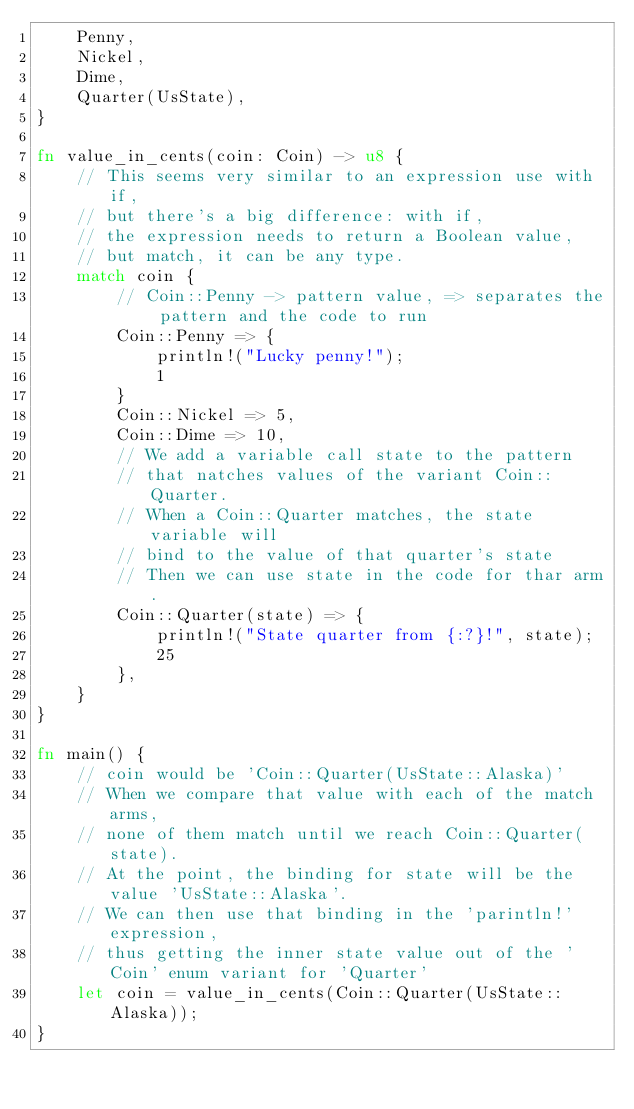Convert code to text. <code><loc_0><loc_0><loc_500><loc_500><_Rust_>    Penny,
    Nickel,
    Dime,
    Quarter(UsState),
}

fn value_in_cents(coin: Coin) -> u8 {
    // This seems very similar to an expression use with if,
    // but there's a big difference: with if,
    // the expression needs to return a Boolean value,
    // but match, it can be any type.
    match coin {
        // Coin::Penny -> pattern value, => separates the pattern and the code to run
        Coin::Penny => {
            println!("Lucky penny!");
            1
        }
        Coin::Nickel => 5,
        Coin::Dime => 10,
        // We add a variable call state to the pattern 
        // that natches values of the variant Coin::Quarter.
        // When a Coin::Quarter matches, the state variable will
        // bind to the value of that quarter's state
        // Then we can use state in the code for thar arm.
        Coin::Quarter(state) => {
            println!("State quarter from {:?}!", state);
            25
        },
    }
}

fn main() {
    // coin would be 'Coin::Quarter(UsState::Alaska)'
    // When we compare that value with each of the match arms, 
    // none of them match until we reach Coin::Quarter(state).
    // At the point, the binding for state will be the value 'UsState::Alaska'.
    // We can then use that binding in the 'parintln!' expression,
    // thus getting the inner state value out of the 'Coin' enum variant for 'Quarter'
    let coin = value_in_cents(Coin::Quarter(UsState::Alaska));
}
</code> 